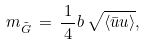Convert formula to latex. <formula><loc_0><loc_0><loc_500><loc_500>m _ { \tilde { G } } \, = \, \frac { \, 1 \, } { \, 4 \, } b \, \sqrt { \langle \bar { u } u \rangle } ,</formula> 